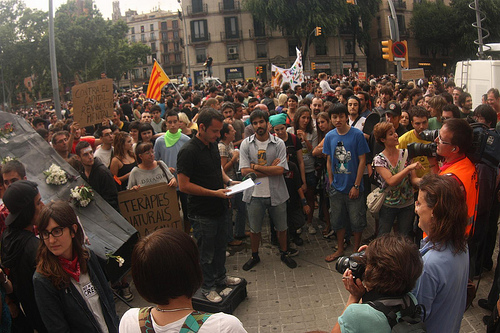<image>
Is there a woman to the left of the man? Yes. From this viewpoint, the woman is positioned to the left side relative to the man. Where is the flag in relation to the man? Is it behind the man? Yes. From this viewpoint, the flag is positioned behind the man, with the man partially or fully occluding the flag. 